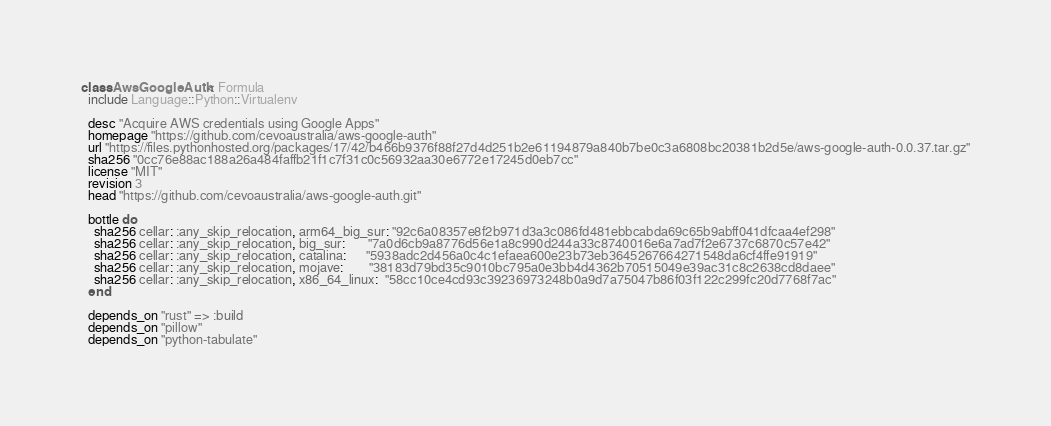Convert code to text. <code><loc_0><loc_0><loc_500><loc_500><_Ruby_>class AwsGoogleAuth < Formula
  include Language::Python::Virtualenv

  desc "Acquire AWS credentials using Google Apps"
  homepage "https://github.com/cevoaustralia/aws-google-auth"
  url "https://files.pythonhosted.org/packages/17/42/b466b9376f88f27d4d251b2e61194879a840b7be0c3a6808bc20381b2d5e/aws-google-auth-0.0.37.tar.gz"
  sha256 "0cc76e88ac188a26a484faffb21f1c7f31c0c56932aa30e6772e17245d0eb7cc"
  license "MIT"
  revision 3
  head "https://github.com/cevoaustralia/aws-google-auth.git"

  bottle do
    sha256 cellar: :any_skip_relocation, arm64_big_sur: "92c6a08357e8f2b971d3a3c086fd481ebbcabda69c65b9abff041dfcaa4ef298"
    sha256 cellar: :any_skip_relocation, big_sur:       "7a0d6cb9a8776d56e1a8c990d244a33c8740016e6a7ad7f2e6737c6870c57e42"
    sha256 cellar: :any_skip_relocation, catalina:      "5938adc2d456a0c4c1efaea600e23b73eb3645267664271548da6cf4ffe91919"
    sha256 cellar: :any_skip_relocation, mojave:        "38183d79bd35c9010bc795a0e3bb4d4362b70515049e39ac31c8c2638cd8daee"
    sha256 cellar: :any_skip_relocation, x86_64_linux:  "58cc10ce4cd93c39236973248b0a9d7a75047b86f03f122c299fc20d7768f7ac"
  end

  depends_on "rust" => :build
  depends_on "pillow"
  depends_on "python-tabulate"</code> 